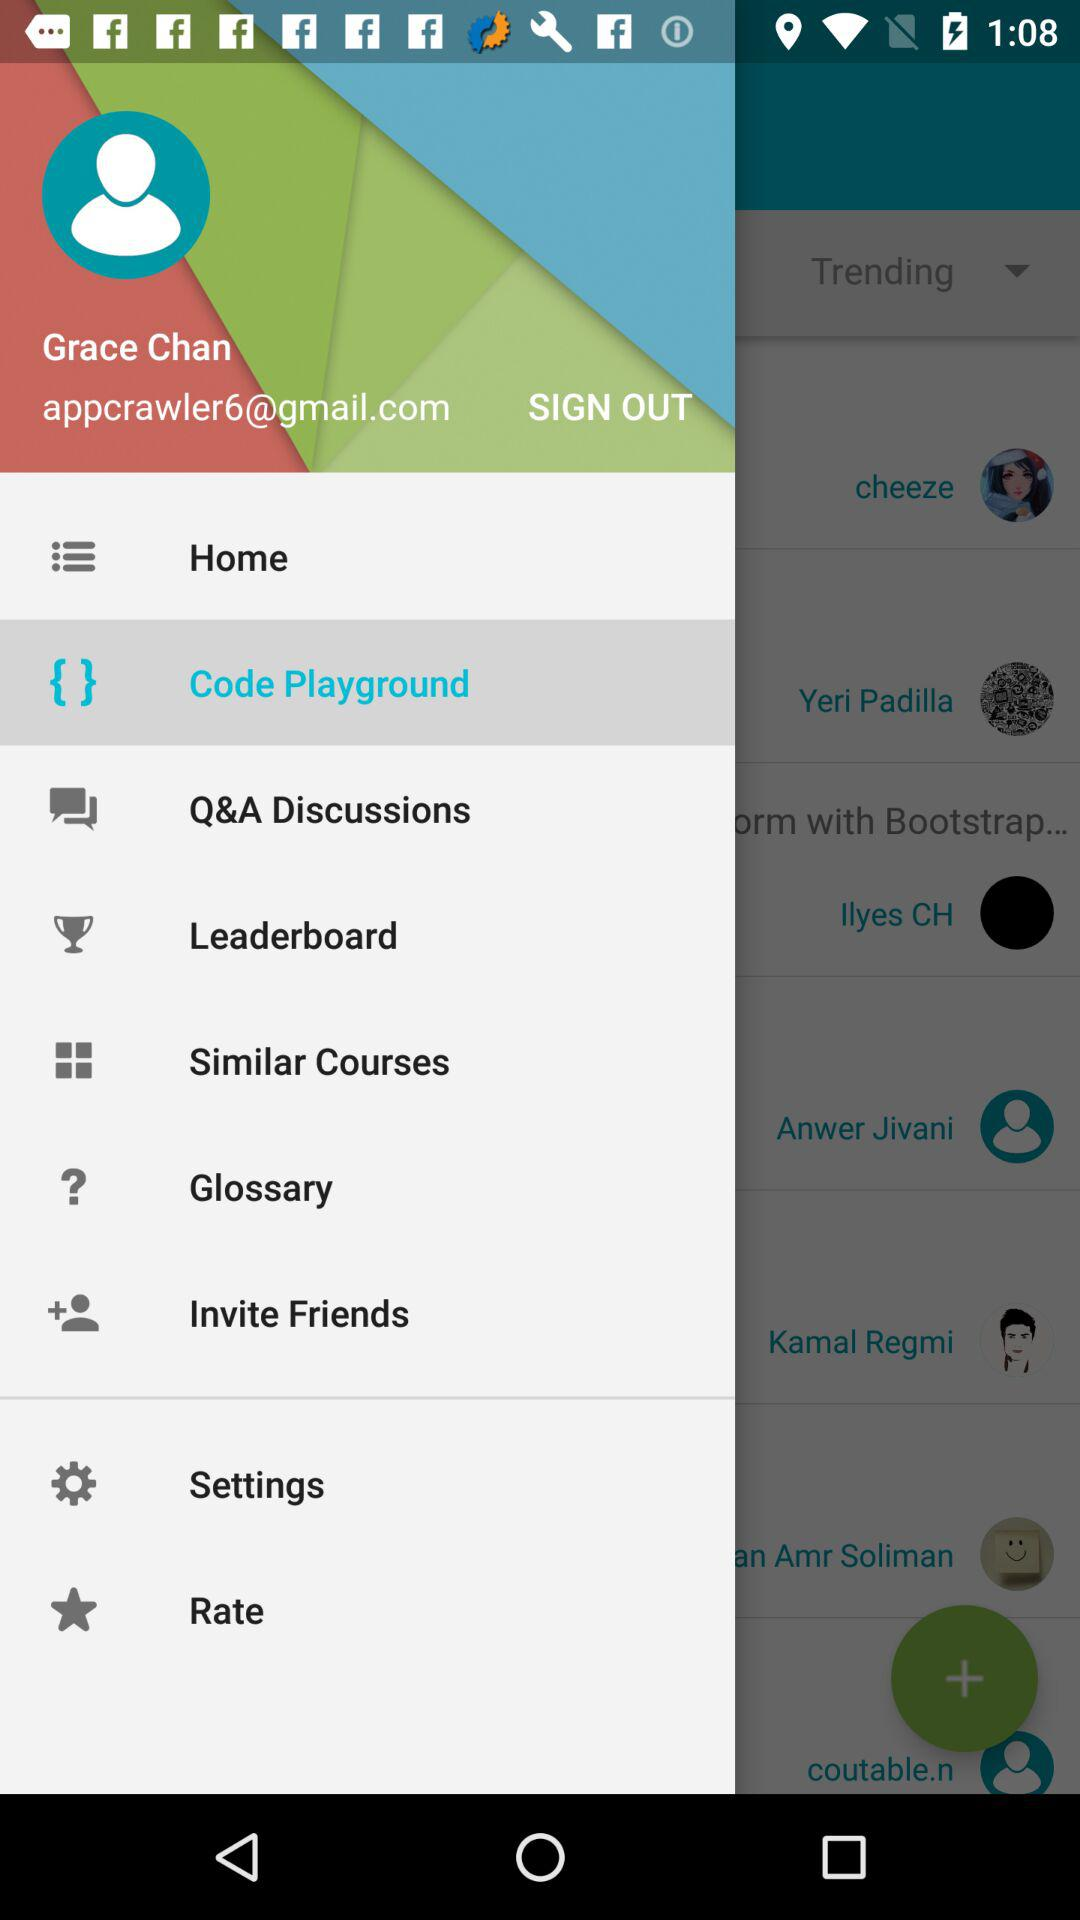What is an email address? The email address is appcrawler6@gmail.com. 